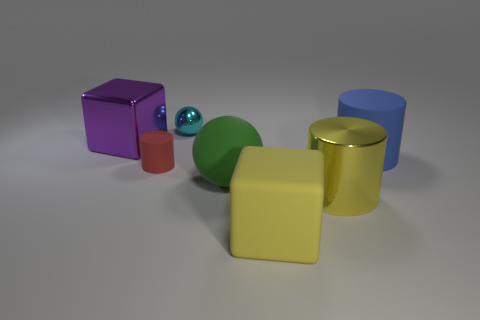Subtract all purple balls. Subtract all purple cylinders. How many balls are left? 2 Add 2 big purple metallic cubes. How many objects exist? 9 Subtract all cylinders. How many objects are left? 4 Subtract all big yellow metallic things. Subtract all purple shiny objects. How many objects are left? 5 Add 1 big rubber blocks. How many big rubber blocks are left? 2 Add 2 large green balls. How many large green balls exist? 3 Subtract 0 brown cylinders. How many objects are left? 7 